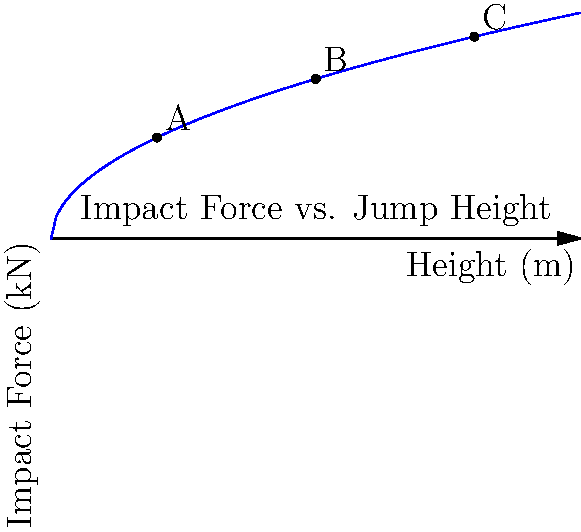Based on the graph showing the relationship between jump height and impact force on bones, which point represents the safest jumping height for a child weighing 35 kg to escape a burning building, considering the trade-off between injury risk and escape feasibility? To determine the safest jumping height, we need to consider both the impact force and the practicality of the jump. Let's analyze each point:

1. Calculate the impact force for each point:
   - Point A (2m): $F_A = \sqrt{2 \cdot 9.81 \cdot 2} \cdot 35 \cdot 3.5 \approx 6.8$ kN
   - Point B (5m): $F_B = \sqrt{2 \cdot 9.81 \cdot 5} \cdot 35 \cdot 3.5 \approx 10.8$ kN
   - Point C (8m): $F_C = \sqrt{2 \cdot 9.81 \cdot 8} \cdot 35 \cdot 3.5 \approx 13.7$ kN

2. Consider the impact force threshold:
   - The average child's bones can withstand forces up to about 8-10 kN before fracturing.

3. Evaluate the practicality of each height:
   - 2m: Easily achievable for most children, lowest impact force.
   - 5m: Challenging but possible, moderate impact force.
   - 8m: Very difficult and dangerous, highest impact force.

4. Assess the risk vs. benefit:
   - Point A (2m) has the lowest impact force and is the most practical height for a child to jump from.
   - Points B and C have impact forces that exceed the safe threshold for children's bones.

5. Consider the fire safety context:
   - In a fire emergency, quick escape is crucial, and lower heights are generally safer and more accessible.

Therefore, Point A (2m) represents the safest jumping height for a child weighing 35 kg, balancing the need for a quick escape with the lowest risk of bone injury.
Answer: Point A (2m) 